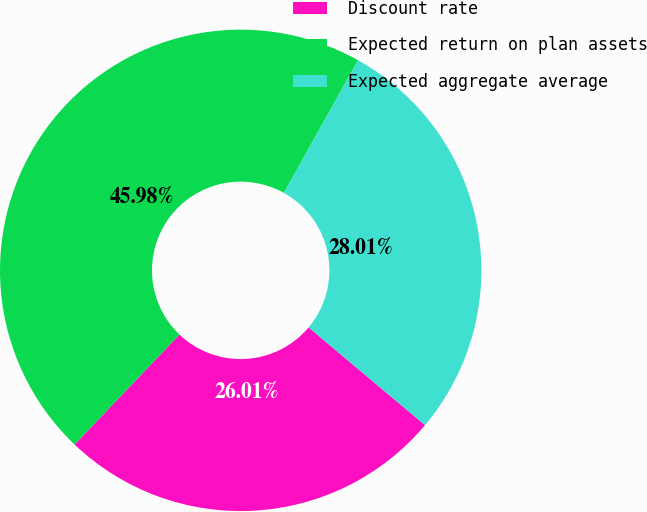Convert chart to OTSL. <chart><loc_0><loc_0><loc_500><loc_500><pie_chart><fcel>Discount rate<fcel>Expected return on plan assets<fcel>Expected aggregate average<nl><fcel>26.01%<fcel>45.98%<fcel>28.01%<nl></chart> 